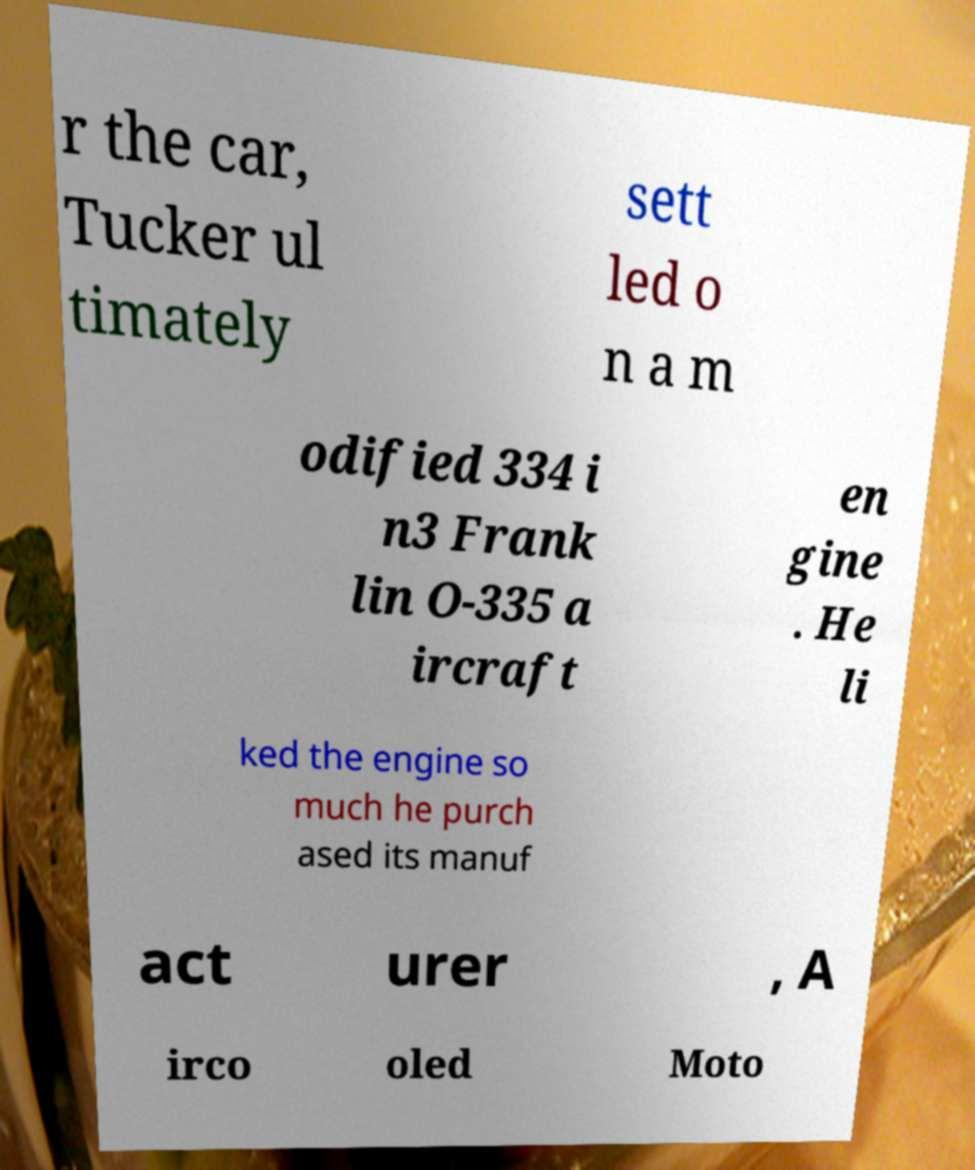Please identify and transcribe the text found in this image. r the car, Tucker ul timately sett led o n a m odified 334 i n3 Frank lin O-335 a ircraft en gine . He li ked the engine so much he purch ased its manuf act urer , A irco oled Moto 